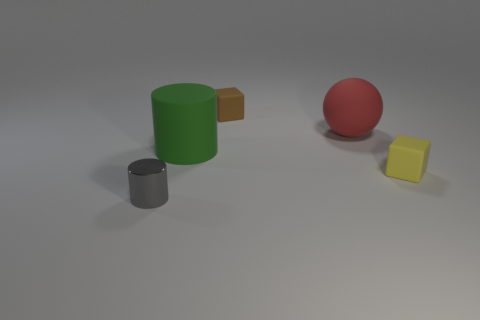There is another object that is the same shape as the gray metallic thing; what size is it?
Your answer should be very brief. Large. How many other big green cylinders are the same material as the green cylinder?
Offer a very short reply. 0. What number of things are either small yellow matte cylinders or gray metallic cylinders?
Offer a terse response. 1. There is a cylinder behind the gray metal cylinder; is there a matte thing that is behind it?
Your answer should be compact. Yes. Is the number of tiny rubber cubes that are behind the small gray metallic object greater than the number of small cylinders on the right side of the yellow matte thing?
Offer a very short reply. Yes. How many tiny rubber blocks have the same color as the large matte cylinder?
Your answer should be compact. 0. There is a tiny brown matte block; are there any brown things behind it?
Provide a short and direct response. No. What is the material of the yellow block?
Keep it short and to the point. Rubber. What is the shape of the small rubber object that is behind the red rubber object?
Make the answer very short. Cube. Is there a purple metallic cylinder that has the same size as the yellow matte thing?
Your response must be concise. No. 